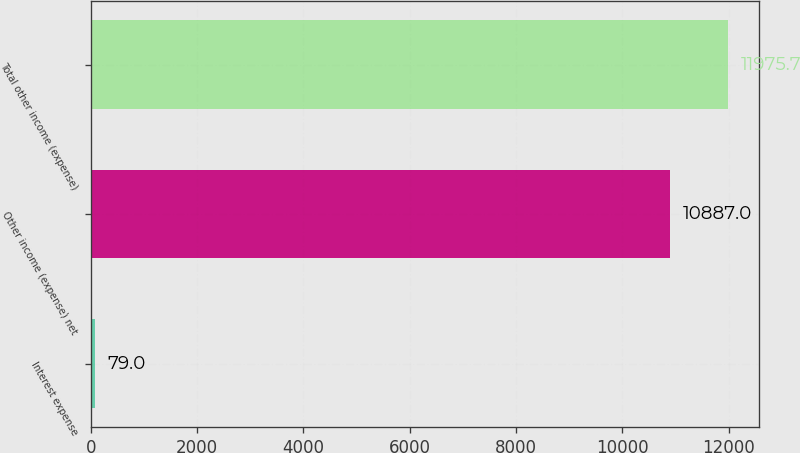Convert chart. <chart><loc_0><loc_0><loc_500><loc_500><bar_chart><fcel>Interest expense<fcel>Other income (expense) net<fcel>Total other income (expense)<nl><fcel>79<fcel>10887<fcel>11975.7<nl></chart> 